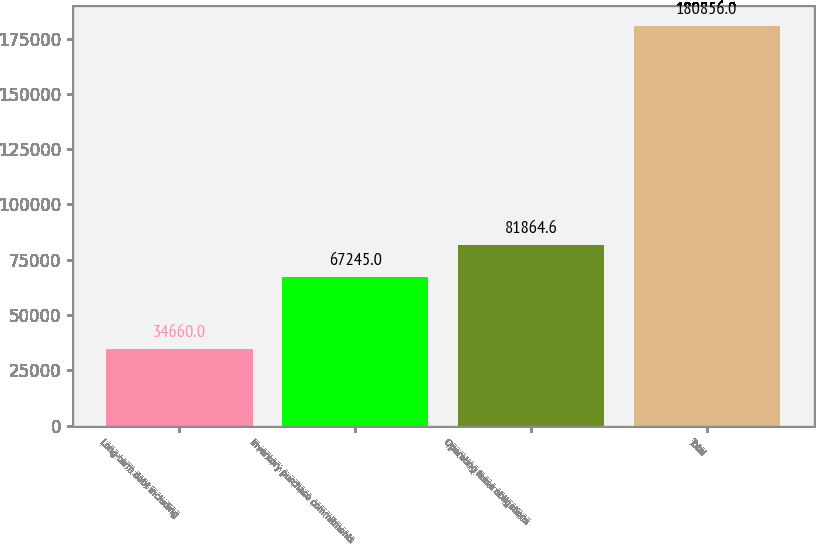<chart> <loc_0><loc_0><loc_500><loc_500><bar_chart><fcel>Long-term debt including<fcel>Inventory purchase commitments<fcel>Operating lease obligations<fcel>Total<nl><fcel>34660<fcel>67245<fcel>81864.6<fcel>180856<nl></chart> 